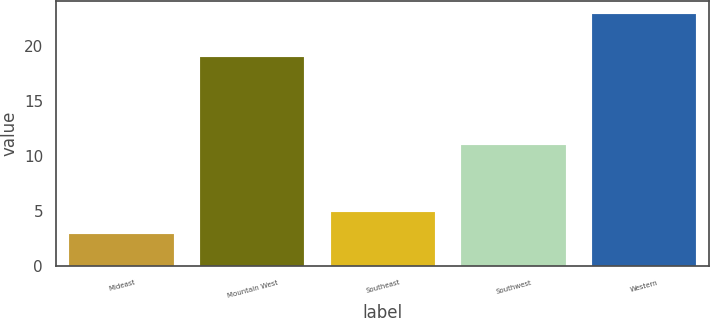Convert chart. <chart><loc_0><loc_0><loc_500><loc_500><bar_chart><fcel>Mideast<fcel>Mountain West<fcel>Southeast<fcel>Southwest<fcel>Western<nl><fcel>2.9<fcel>19<fcel>4.91<fcel>11<fcel>23<nl></chart> 